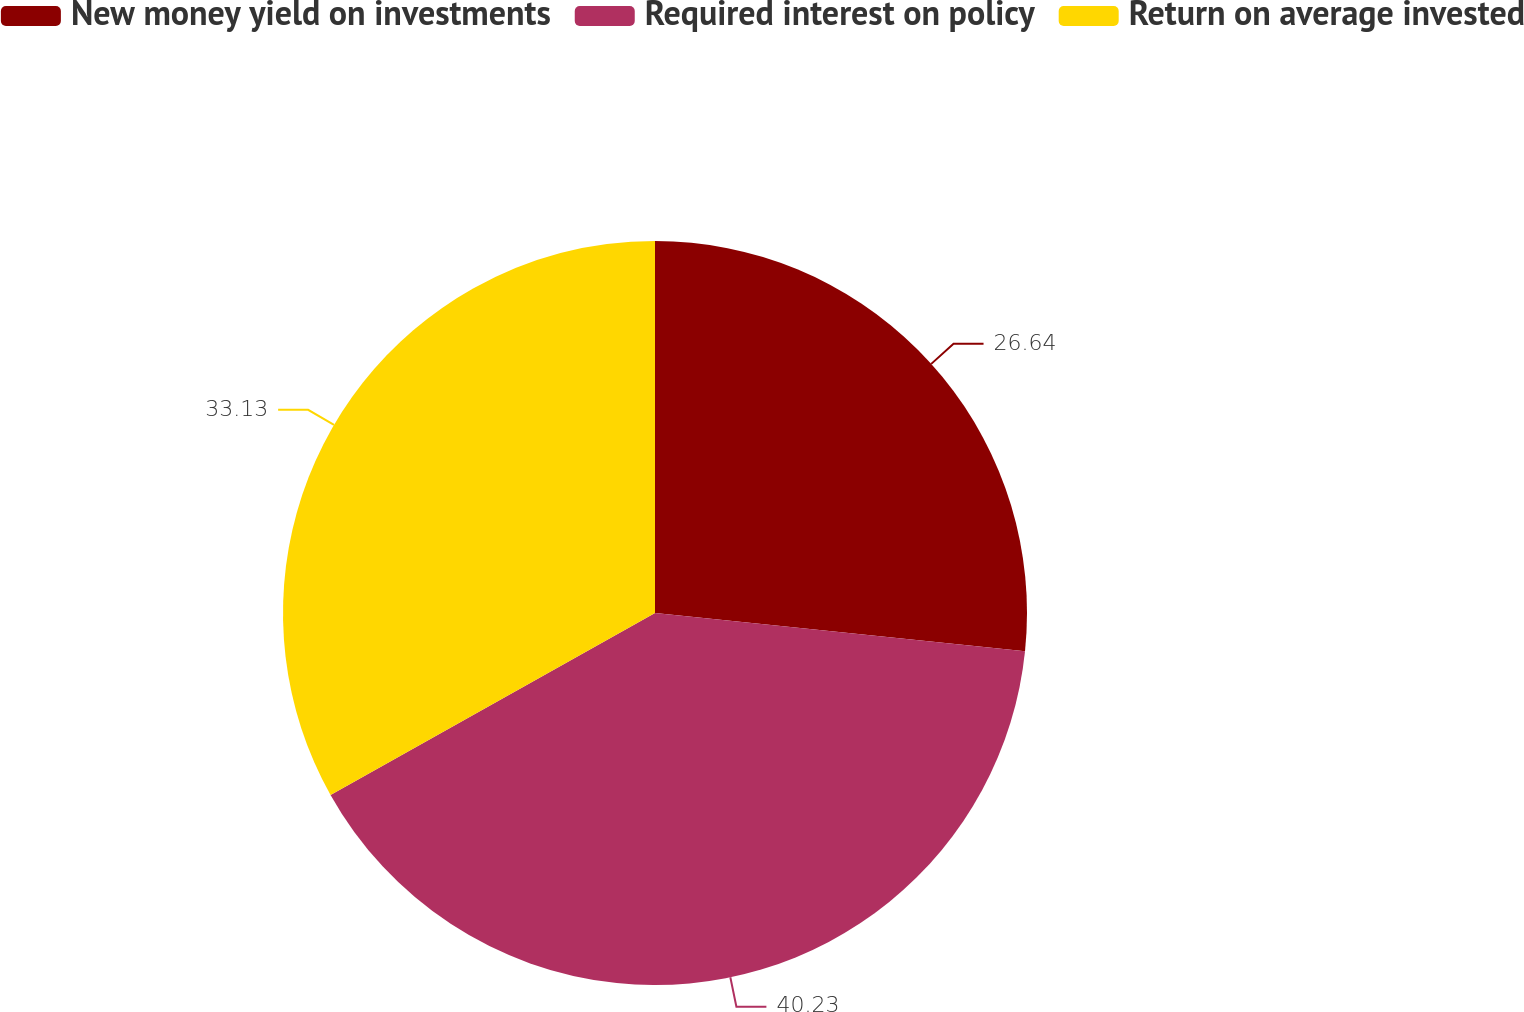<chart> <loc_0><loc_0><loc_500><loc_500><pie_chart><fcel>New money yield on investments<fcel>Required interest on policy<fcel>Return on average invested<nl><fcel>26.64%<fcel>40.22%<fcel>33.13%<nl></chart> 